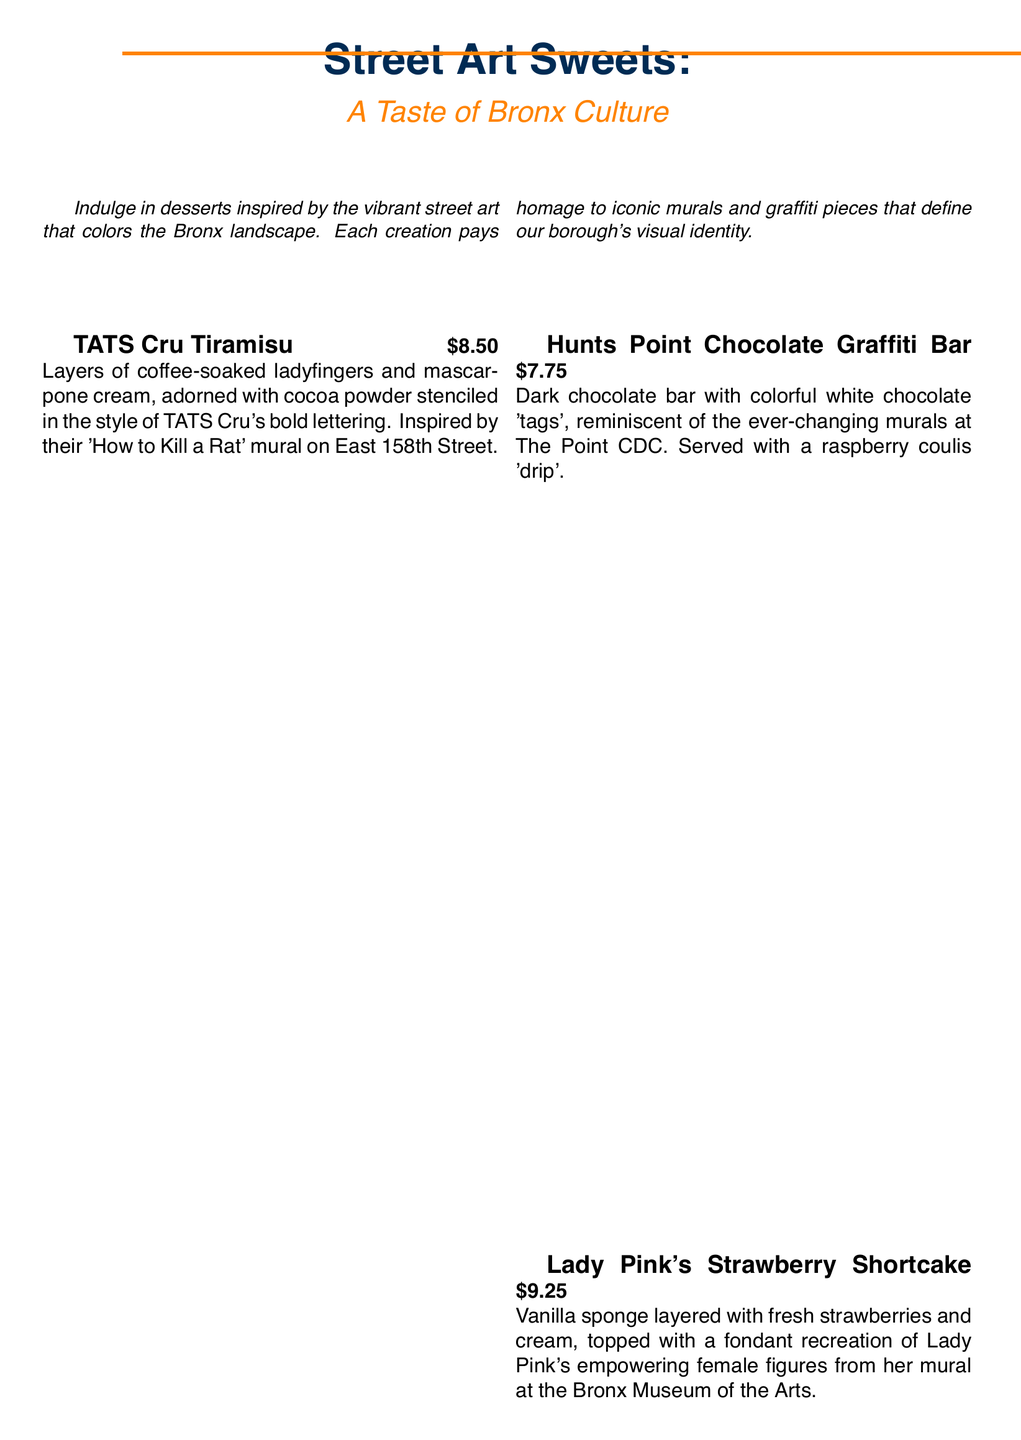What is the name of the dessert inspired by TATS Cru? The dessert inspired by TATS Cru is called "TATS Cru Tiramisu."
Answer: TATS Cru Tiramisu How much does the Hunts Point Chocolate Graffiti Bar cost? The price of the Hunts Point Chocolate Graffiti Bar is listed as $7.75.
Answer: $7.75 Which pastry is inspired by Lady Pink? The pastry inspired by Lady Pink is "Lady Pink's Strawberry Shortcake."
Answer: Lady Pink's Strawberry Shortcake What unique ingredient is used in Kingbee's Honey Lavender Panna Cotta? The unique ingredient used in Kingbee's Honey Lavender Panna Cotta is local honey and lavender.
Answer: local honey and lavender How many macarons are in the Grand Concourse Galaxy Macaron dessert? The Grand Concourse Galaxy Macaron dessert features a trio of macarons.
Answer: trio What artwork inspired the Cocoa Powder design on TATS Cru Tiramisu? The Cocoa Powder design is inspired by TATS Cru's 'How to Kill a Rat' mural.
Answer: 'How to Kill a Rat' mural Which dessert has a raspberry coulis 'drip'? The dessert with a raspberry coulis 'drip' is the Hunts Point Chocolate Graffiti Bar.
Answer: Hunts Point Chocolate Graffiti Bar What is the price of Grand Concourse Galaxy Macaron? The price of the Grand Concourse Galaxy Macaron is $6.50.
Answer: $6.50 What type of cake is used in Lady Pink's Strawberry Shortcake? The type of cake used is vanilla sponge.
Answer: vanilla sponge 